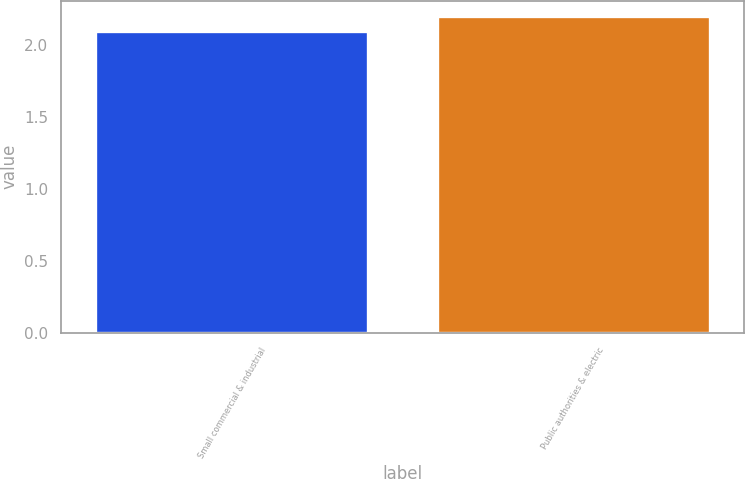Convert chart. <chart><loc_0><loc_0><loc_500><loc_500><bar_chart><fcel>Small commercial & industrial<fcel>Public authorities & electric<nl><fcel>2.1<fcel>2.2<nl></chart> 